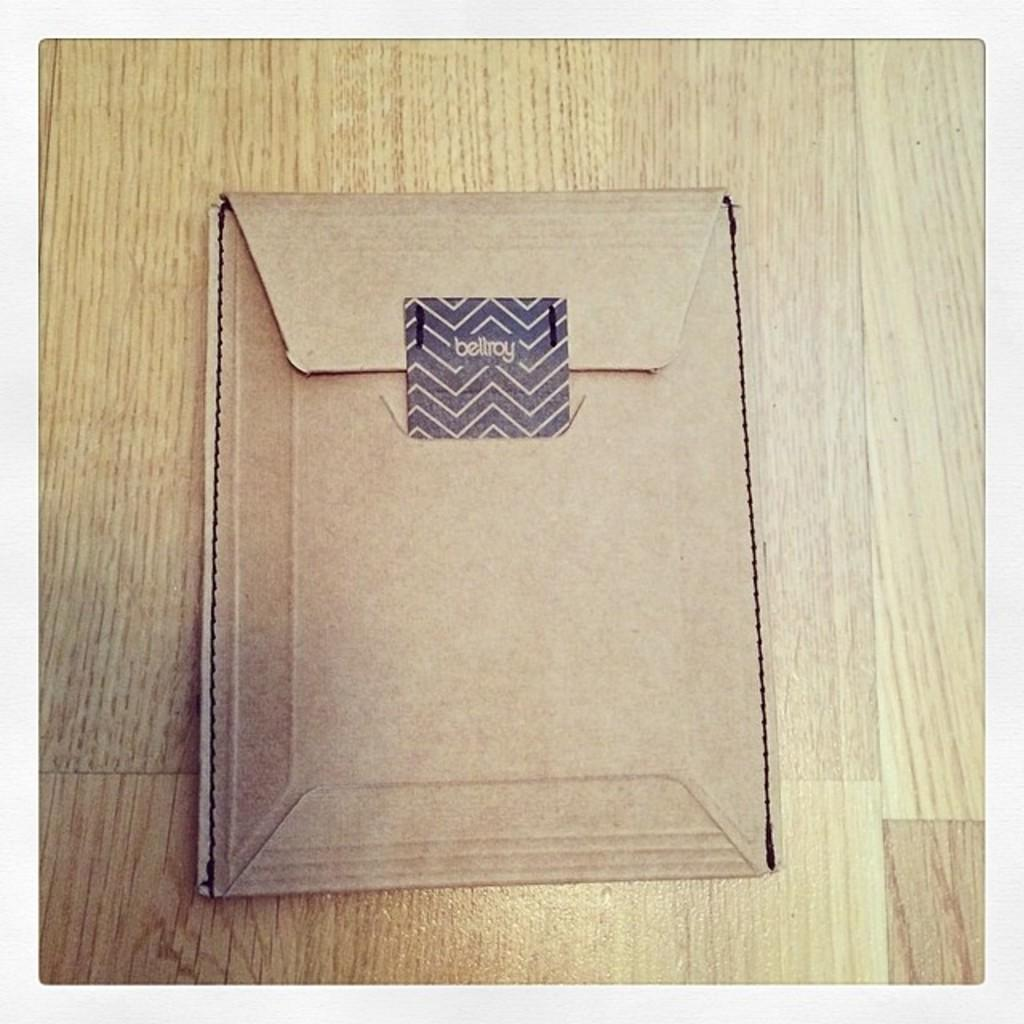<image>
Describe the image concisely. A card  board manilla folder with a black chevron sticker saying beltroy. 